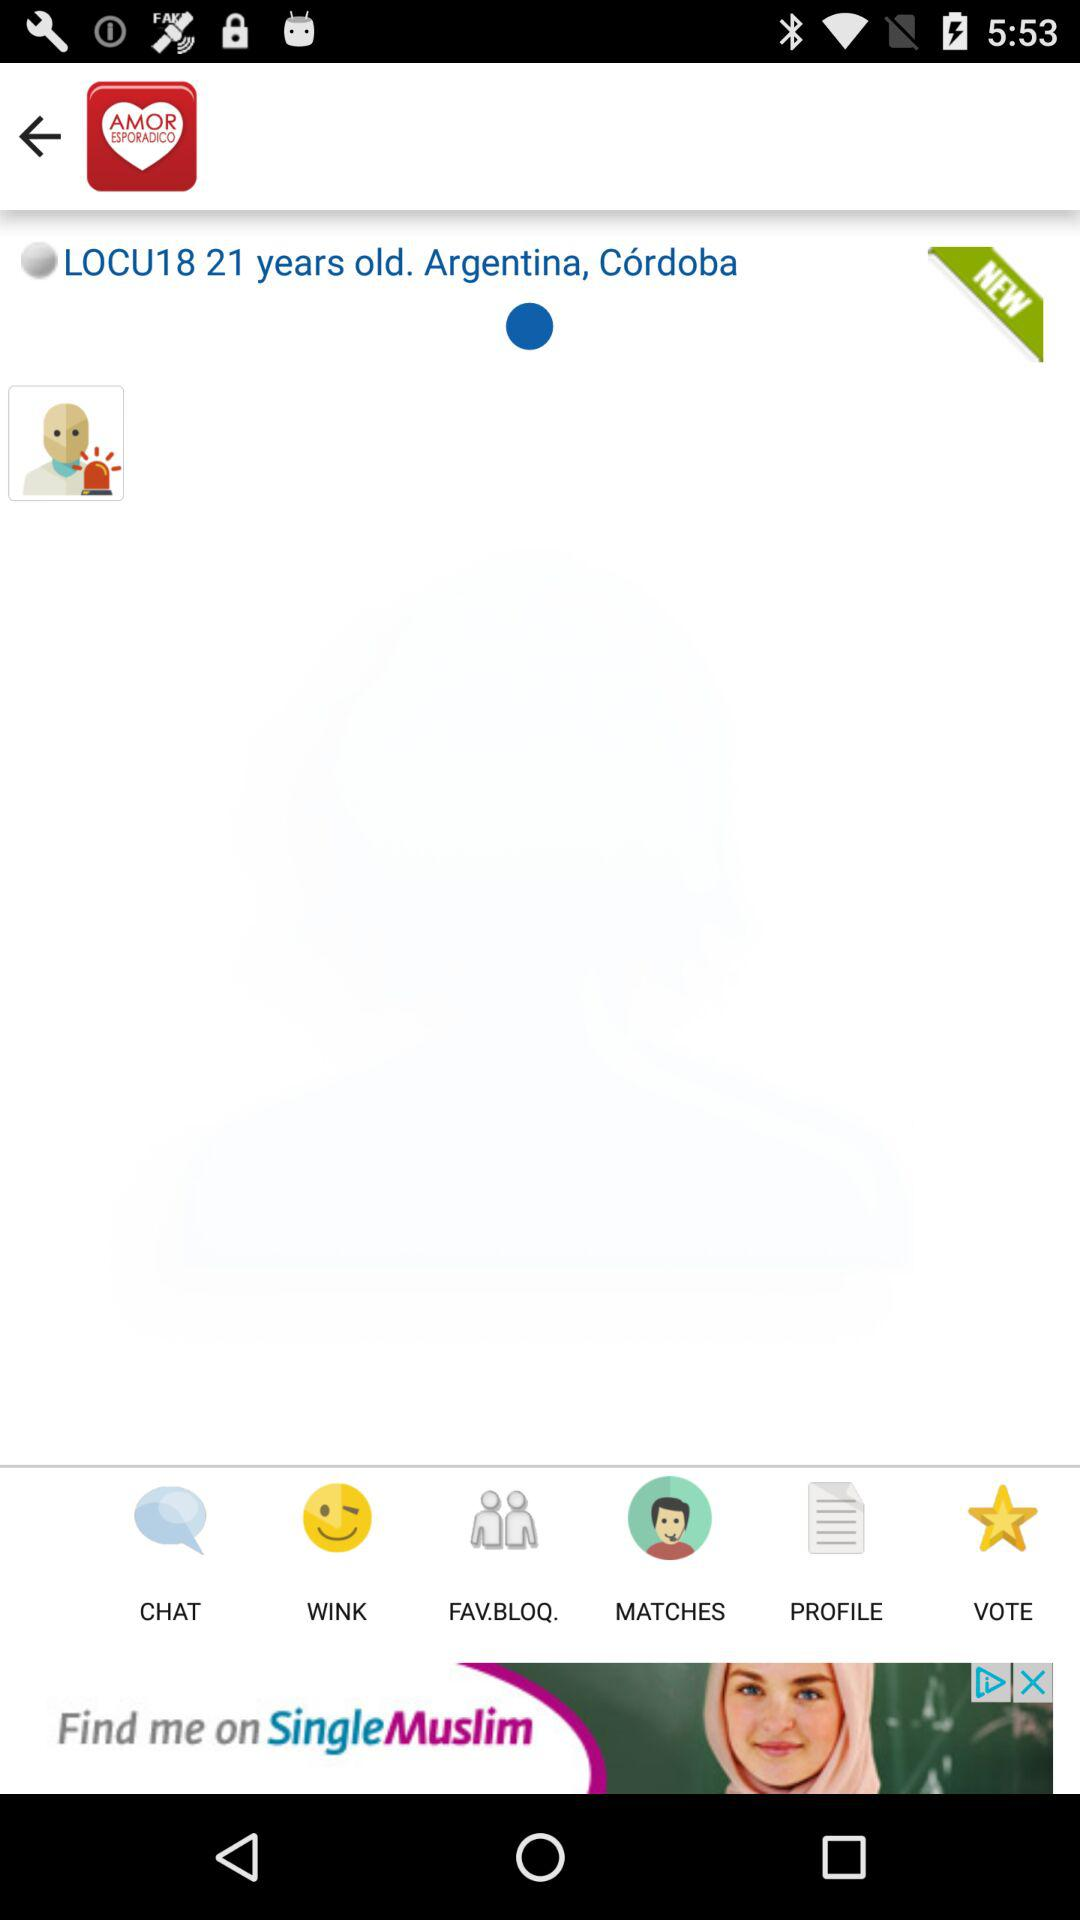What is the age of the user? The age of the user is 21 years old. 